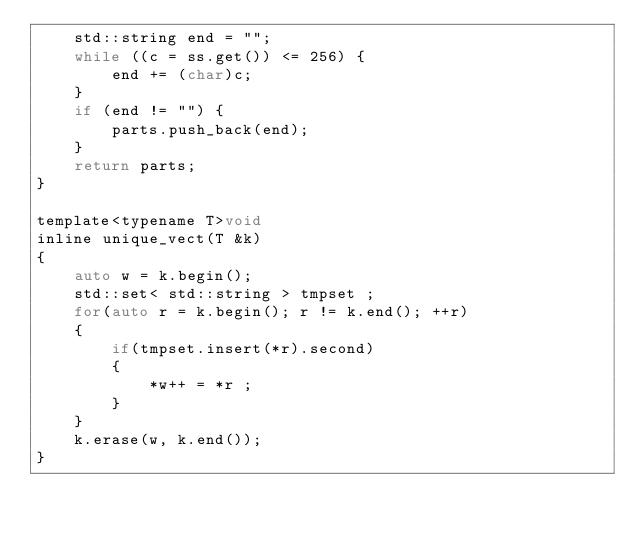<code> <loc_0><loc_0><loc_500><loc_500><_C_>    std::string end = "";
    while ((c = ss.get()) <= 256) {
        end += (char)c;
    }
    if (end != "") {
        parts.push_back(end);
    }
    return parts;
}

template<typename T>void 
inline unique_vect(T &k)
{
    auto w = k.begin();
    std::set< std::string > tmpset ;
    for(auto r = k.begin(); r != k.end(); ++r)
    {
        if(tmpset.insert(*r).second)
        {
            *w++ = *r ;
        }
    }
    k.erase(w, k.end());
}
</code> 